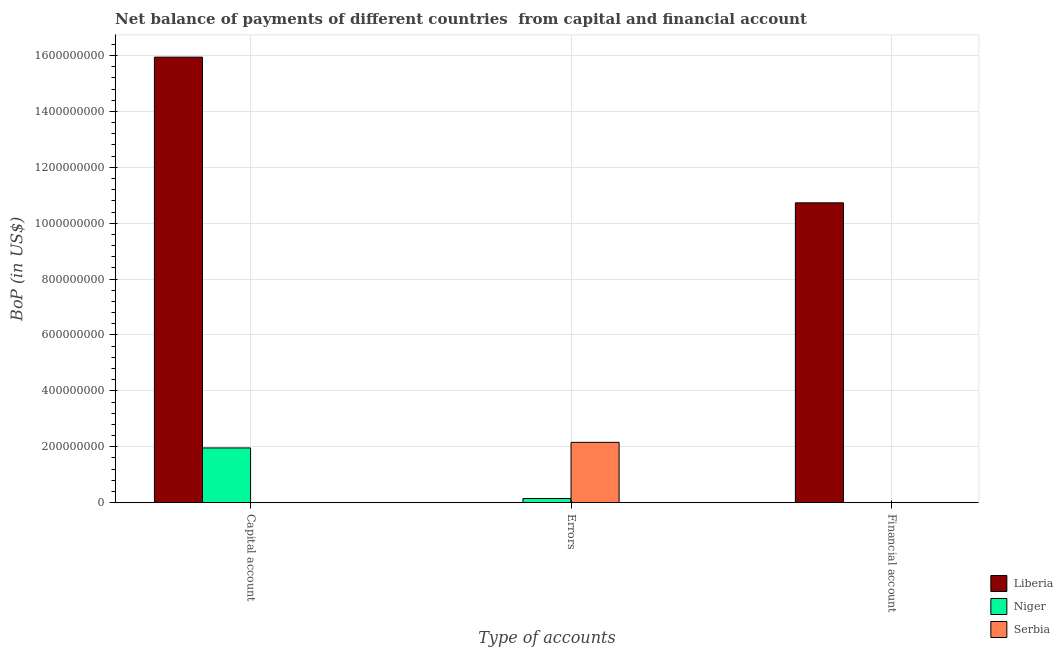How many different coloured bars are there?
Your answer should be very brief. 3. Are the number of bars on each tick of the X-axis equal?
Your answer should be compact. No. What is the label of the 3rd group of bars from the left?
Make the answer very short. Financial account. What is the amount of net capital account in Liberia?
Offer a terse response. 1.59e+09. Across all countries, what is the maximum amount of errors?
Provide a succinct answer. 2.16e+08. Across all countries, what is the minimum amount of net capital account?
Give a very brief answer. 0. In which country was the amount of net capital account maximum?
Your answer should be very brief. Liberia. What is the total amount of net capital account in the graph?
Your answer should be very brief. 1.79e+09. What is the difference between the amount of errors in Serbia and that in Niger?
Your answer should be very brief. 2.01e+08. What is the difference between the amount of net capital account in Niger and the amount of financial account in Liberia?
Keep it short and to the point. -8.77e+08. What is the average amount of financial account per country?
Your answer should be very brief. 3.58e+08. What is the difference between the amount of errors and amount of net capital account in Niger?
Your response must be concise. -1.81e+08. In how many countries, is the amount of net capital account greater than 1000000000 US$?
Offer a very short reply. 1. Is the amount of net capital account in Niger less than that in Liberia?
Provide a short and direct response. Yes. What is the difference between the highest and the lowest amount of net capital account?
Keep it short and to the point. 1.59e+09. In how many countries, is the amount of net capital account greater than the average amount of net capital account taken over all countries?
Provide a short and direct response. 1. How many bars are there?
Make the answer very short. 5. How many countries are there in the graph?
Keep it short and to the point. 3. What is the difference between two consecutive major ticks on the Y-axis?
Keep it short and to the point. 2.00e+08. Are the values on the major ticks of Y-axis written in scientific E-notation?
Keep it short and to the point. No. Does the graph contain grids?
Offer a very short reply. Yes. Where does the legend appear in the graph?
Give a very brief answer. Bottom right. How are the legend labels stacked?
Keep it short and to the point. Vertical. What is the title of the graph?
Provide a short and direct response. Net balance of payments of different countries  from capital and financial account. Does "Belize" appear as one of the legend labels in the graph?
Your answer should be compact. No. What is the label or title of the X-axis?
Provide a succinct answer. Type of accounts. What is the label or title of the Y-axis?
Your answer should be very brief. BoP (in US$). What is the BoP (in US$) in Liberia in Capital account?
Your answer should be very brief. 1.59e+09. What is the BoP (in US$) of Niger in Capital account?
Keep it short and to the point. 1.96e+08. What is the BoP (in US$) of Serbia in Capital account?
Offer a very short reply. 0. What is the BoP (in US$) in Liberia in Errors?
Your response must be concise. 0. What is the BoP (in US$) in Niger in Errors?
Your answer should be very brief. 1.49e+07. What is the BoP (in US$) of Serbia in Errors?
Your answer should be very brief. 2.16e+08. What is the BoP (in US$) in Liberia in Financial account?
Provide a short and direct response. 1.07e+09. Across all Type of accounts, what is the maximum BoP (in US$) of Liberia?
Provide a succinct answer. 1.59e+09. Across all Type of accounts, what is the maximum BoP (in US$) of Niger?
Keep it short and to the point. 1.96e+08. Across all Type of accounts, what is the maximum BoP (in US$) in Serbia?
Give a very brief answer. 2.16e+08. Across all Type of accounts, what is the minimum BoP (in US$) in Liberia?
Your response must be concise. 0. Across all Type of accounts, what is the minimum BoP (in US$) in Niger?
Offer a very short reply. 0. What is the total BoP (in US$) of Liberia in the graph?
Provide a succinct answer. 2.67e+09. What is the total BoP (in US$) in Niger in the graph?
Keep it short and to the point. 2.11e+08. What is the total BoP (in US$) in Serbia in the graph?
Your answer should be compact. 2.16e+08. What is the difference between the BoP (in US$) of Niger in Capital account and that in Errors?
Ensure brevity in your answer.  1.81e+08. What is the difference between the BoP (in US$) in Liberia in Capital account and that in Financial account?
Your answer should be compact. 5.21e+08. What is the difference between the BoP (in US$) of Liberia in Capital account and the BoP (in US$) of Niger in Errors?
Offer a very short reply. 1.58e+09. What is the difference between the BoP (in US$) in Liberia in Capital account and the BoP (in US$) in Serbia in Errors?
Keep it short and to the point. 1.38e+09. What is the difference between the BoP (in US$) in Niger in Capital account and the BoP (in US$) in Serbia in Errors?
Keep it short and to the point. -2.00e+07. What is the average BoP (in US$) in Liberia per Type of accounts?
Give a very brief answer. 8.89e+08. What is the average BoP (in US$) of Niger per Type of accounts?
Offer a terse response. 7.02e+07. What is the average BoP (in US$) in Serbia per Type of accounts?
Offer a very short reply. 7.19e+07. What is the difference between the BoP (in US$) of Liberia and BoP (in US$) of Niger in Capital account?
Provide a short and direct response. 1.40e+09. What is the difference between the BoP (in US$) of Niger and BoP (in US$) of Serbia in Errors?
Make the answer very short. -2.01e+08. What is the ratio of the BoP (in US$) in Niger in Capital account to that in Errors?
Provide a short and direct response. 13.15. What is the ratio of the BoP (in US$) in Liberia in Capital account to that in Financial account?
Give a very brief answer. 1.49. What is the difference between the highest and the lowest BoP (in US$) in Liberia?
Your answer should be very brief. 1.59e+09. What is the difference between the highest and the lowest BoP (in US$) of Niger?
Your answer should be very brief. 1.96e+08. What is the difference between the highest and the lowest BoP (in US$) in Serbia?
Offer a very short reply. 2.16e+08. 